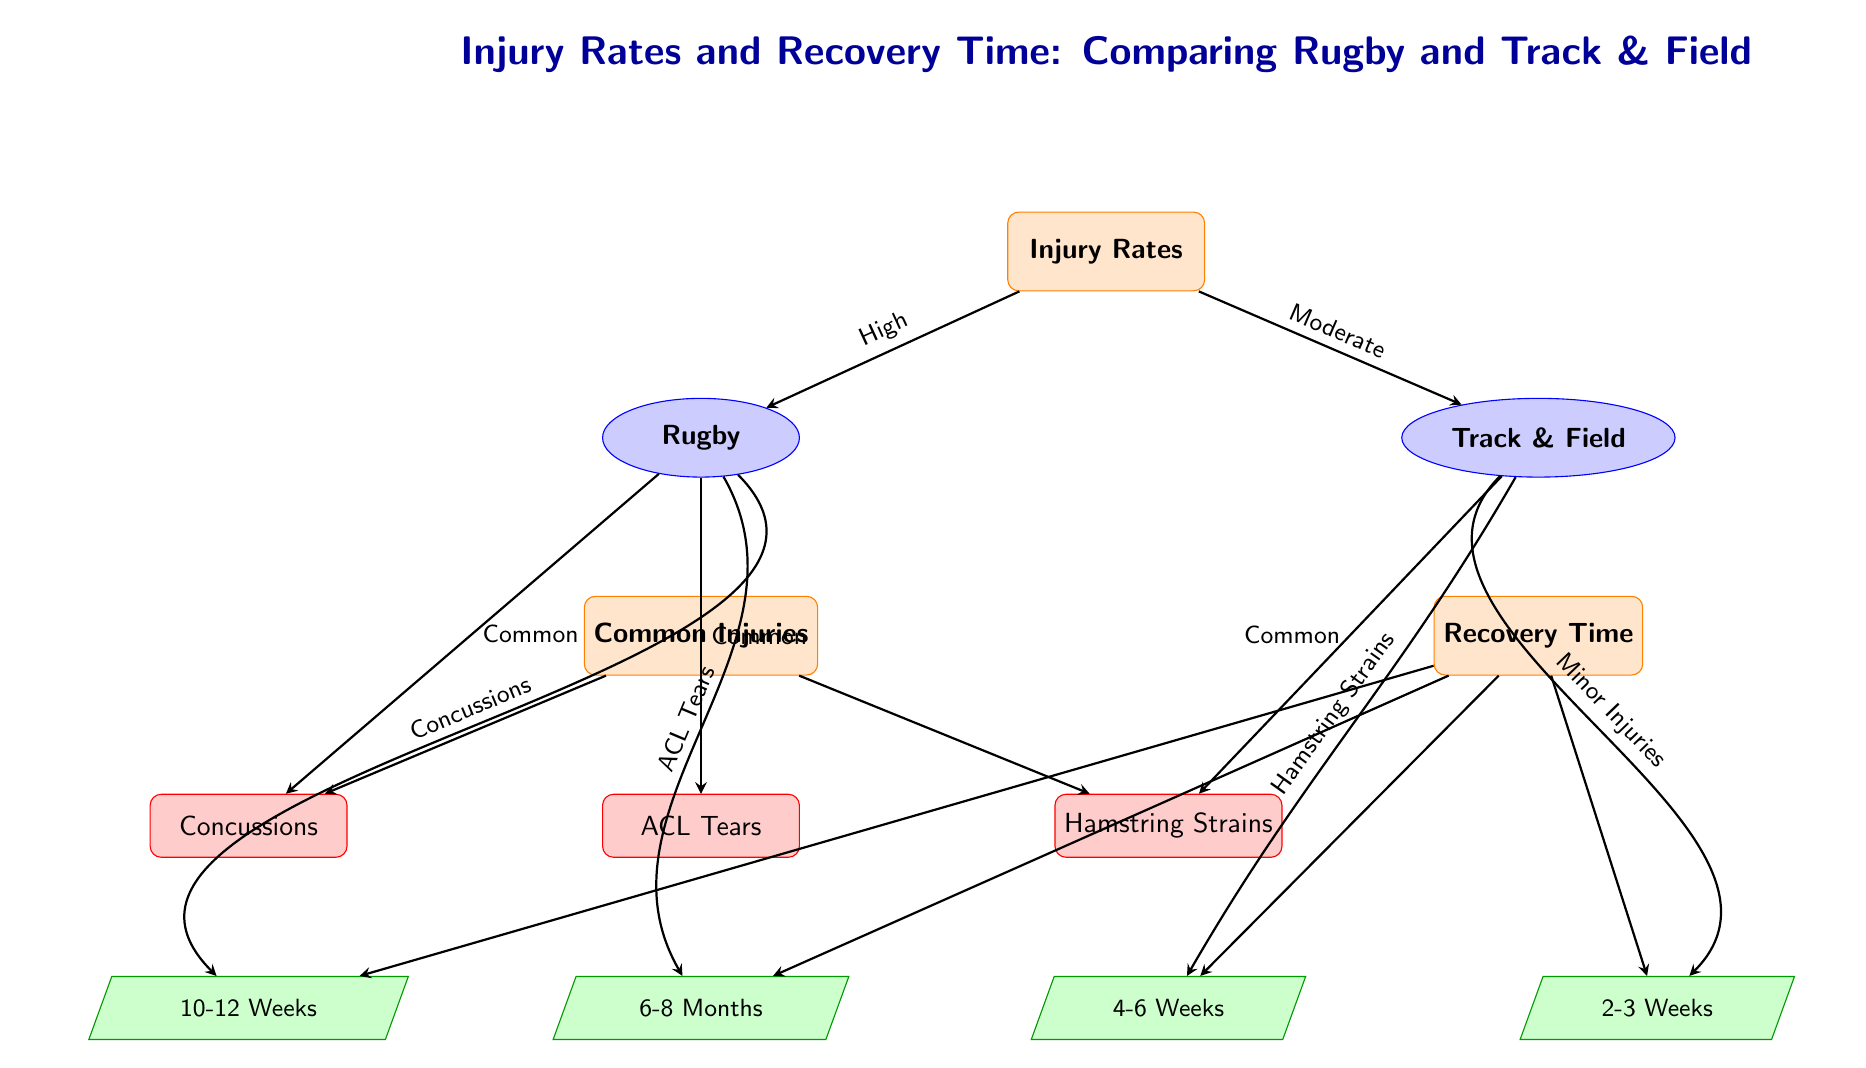What is the injury rate classification for Rugby? The diagram categorizes Rugby under the "High" injury rate classification, indicated by the arrow pointing from "Injury Rates" to "Rugby" with the label "High."
Answer: High What is the recovery time for ACL Tears? The recovery time for ACL Tears is represented in the diagram as "6-8 Months," shown in the trapezium node pointing from "Common Injuries" to "Recovery Time."
Answer: 6-8 Months Which sport is linked to Hamstring Strains? The diagram connects Hamstring Strains with Track & Field, as it points from "Track & Field" to "Hamstring Strains."
Answer: Track & Field How many common injuries are listed for Rugby? The diagram lists two common injuries for Rugby: Concussions and ACL Tears, indicated by their connections from the Rugby node to the injury nodes.
Answer: 2 What is the recovery time for Minor Injuries in Track and Field? The diagram specifies Minor Injuries recovery time as "2-3 Weeks," which is depicted in the trapezium node pointing from the Track & Field node to the Recovery Time section.
Answer: 2-3 Weeks Which sport has a moderate injury rate? The diagram categorically identifies Track & Field as having a "Moderate" injury rate, shown by the arrow from "Injury Rates" to "Track & Field" labeled "Moderate."
Answer: Track & Field What are the common injuries associated with Rugby? The common injuries associated with Rugby are Concussions and ACL Tears, highlighted by the arrows from Rugby to the corresponding injury nodes.
Answer: Concussions, ACL Tears What is the recovery time for Hamstring Strains? The diagram indicates the recovery time for Hamstring Strains as "4-6 Weeks," displayed in the trapezium node under the recovery time section.
Answer: 4-6 Weeks How many total injury categories are classified in the diagram? The diagram classifies three injury categories: Concussions, ACL Tears, and Hamstring Strains, suggesting a count of three injury types overall.
Answer: 3 What type of sports does this diagram compare? The diagram compares high-impact sports, specifically Rugby, with Track & Field events, indicated at the top of the diagram.
Answer: Rugby and Track & Field 